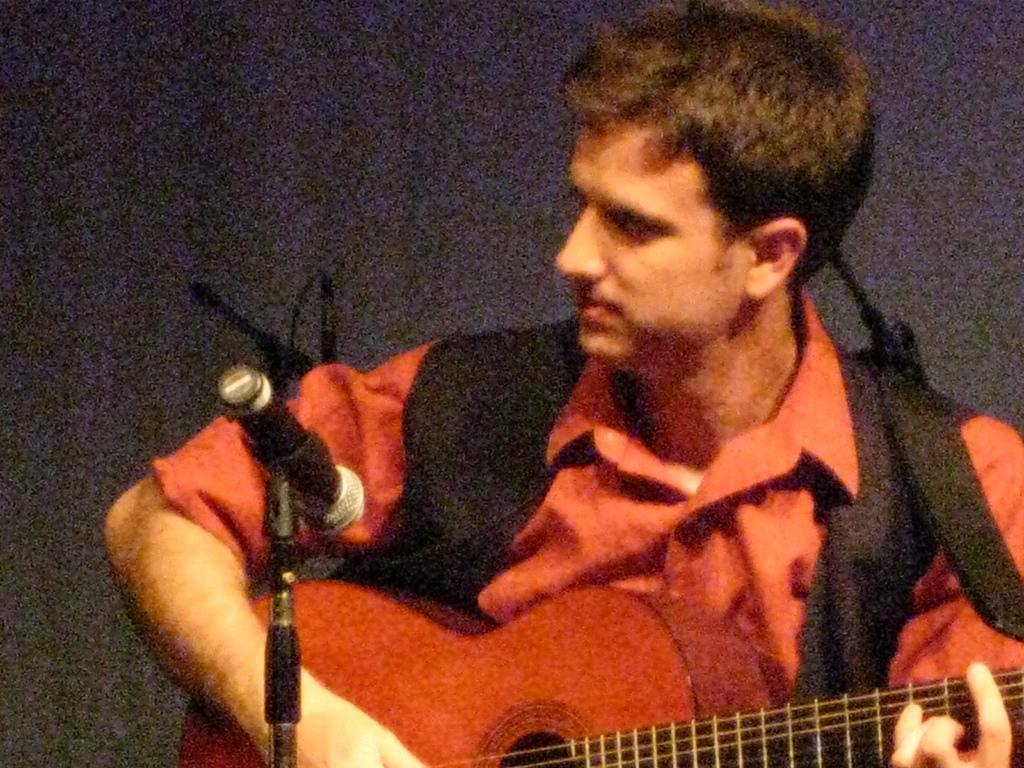Please provide a concise description of this image. In this image there is one man who is playing a guitar in front of him there is one mike, on the background there is a wall. 